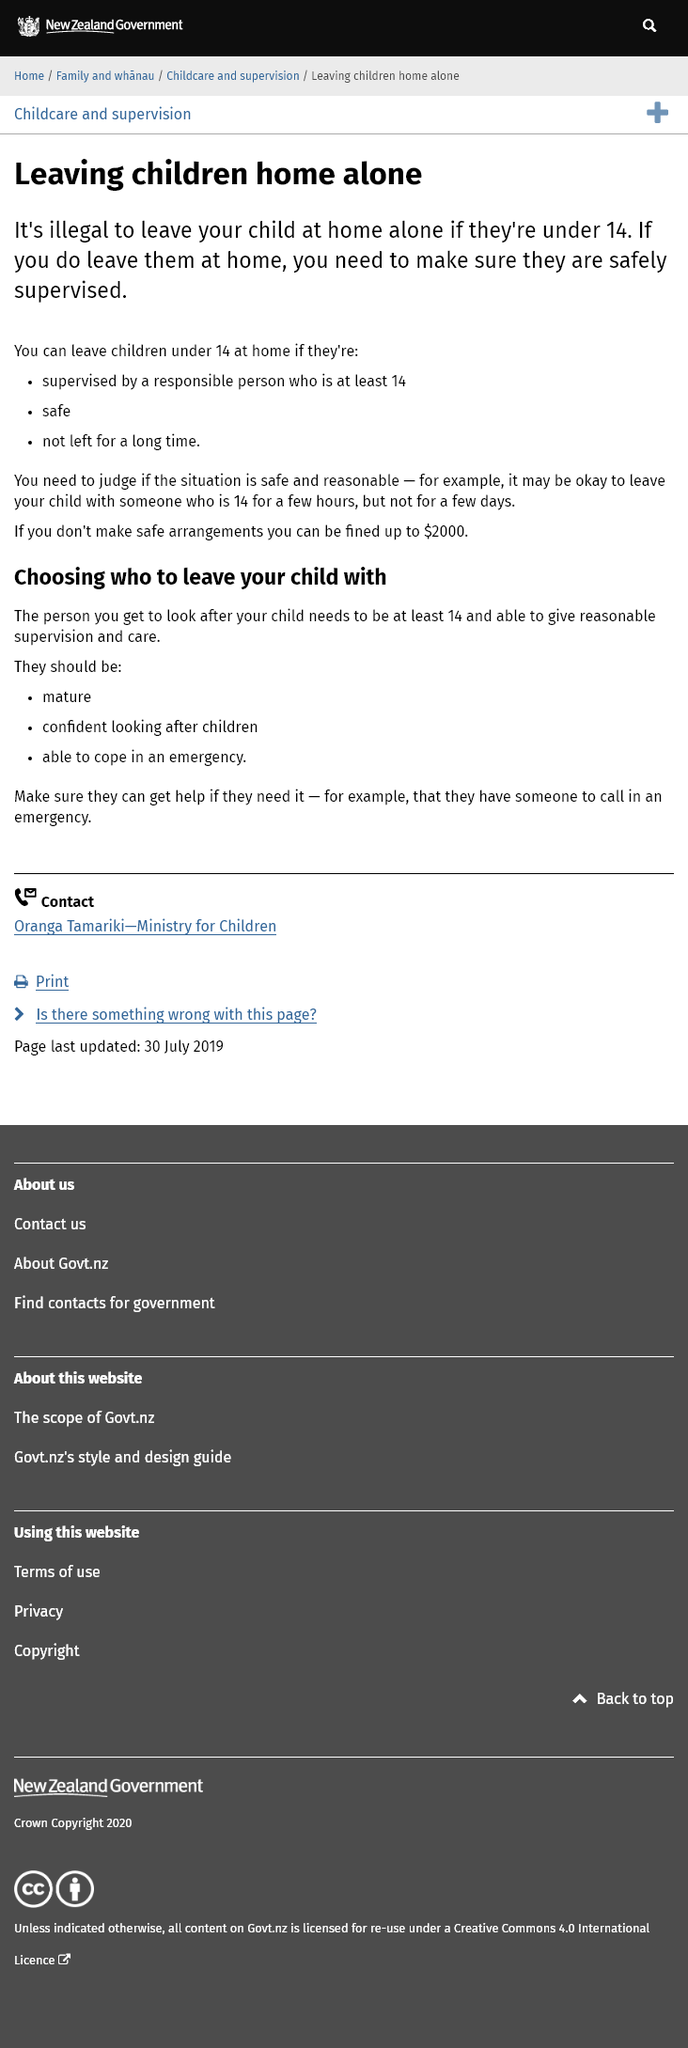Identify some key points in this picture. It is essential that the person staying at home with a child is equipped to handle an emergency situation. If you fail to make safe arrangements, you may be fined up to $2000. It is recommended that the person entrusted with the care of your child be mature and at least 14 years old. 